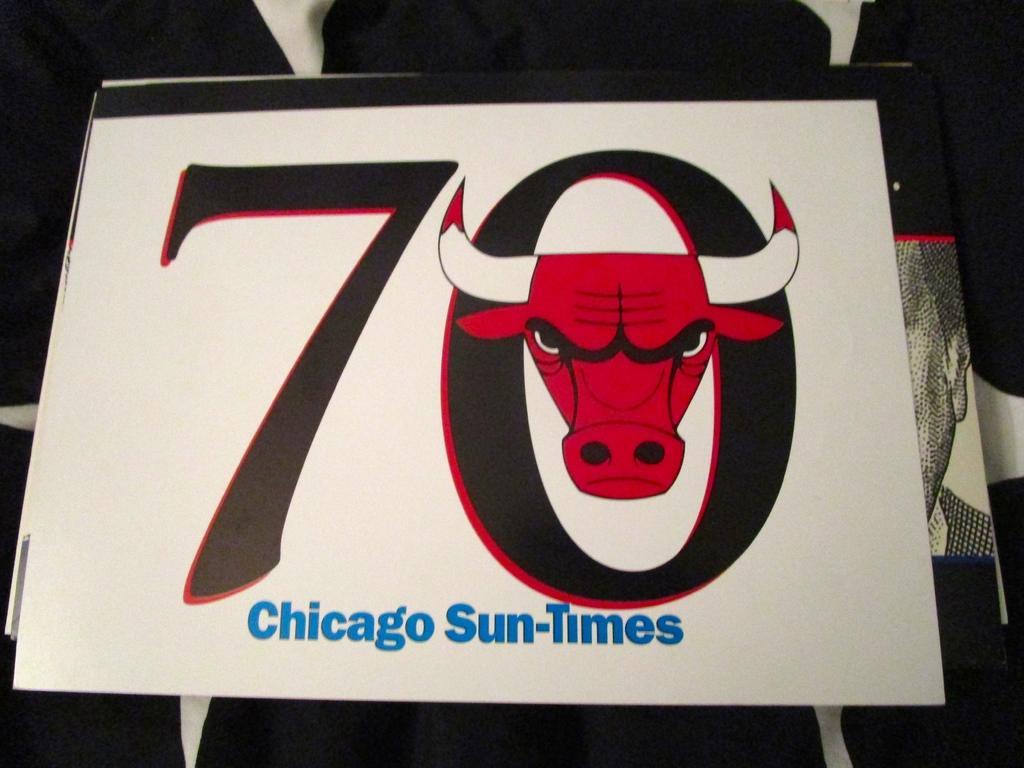Please provide a concise description of this image. In this image, we can see a board contains a bull head, numbers and some text. 